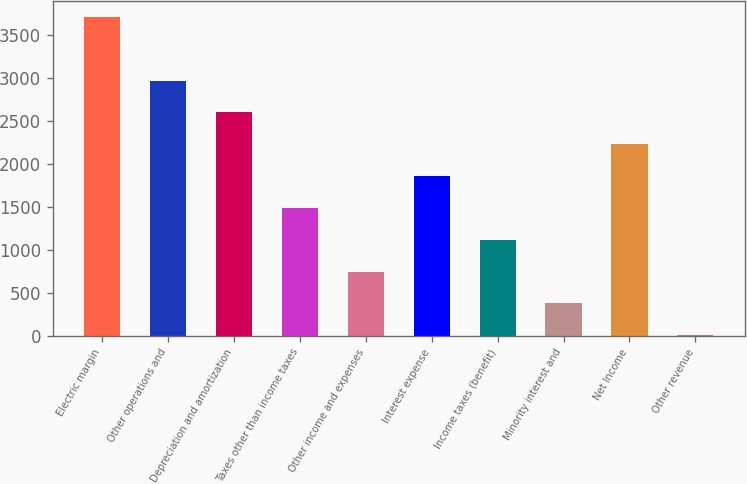<chart> <loc_0><loc_0><loc_500><loc_500><bar_chart><fcel>Electric margin<fcel>Other operations and<fcel>Depreciation and amortization<fcel>Taxes other than income taxes<fcel>Other income and expenses<fcel>Interest expense<fcel>Income taxes (benefit)<fcel>Minority interest and<fcel>Net Income<fcel>Other revenue<nl><fcel>3713<fcel>2971.2<fcel>2600.3<fcel>1487.6<fcel>745.8<fcel>1858.5<fcel>1116.7<fcel>374.9<fcel>2229.4<fcel>4<nl></chart> 